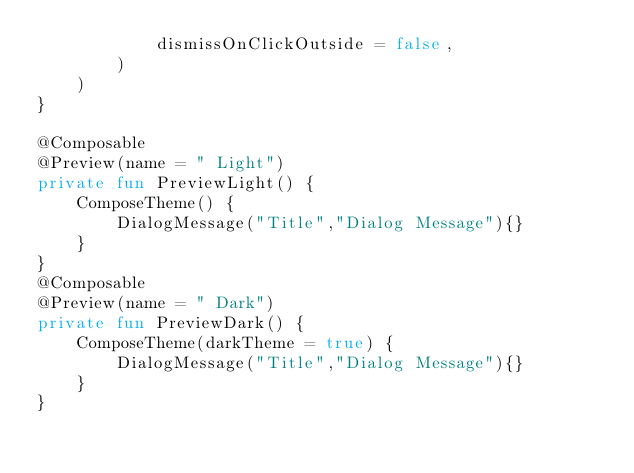Convert code to text. <code><loc_0><loc_0><loc_500><loc_500><_Kotlin_>            dismissOnClickOutside = false,
        )
    )
}

@Composable
@Preview(name = " Light")
private fun PreviewLight() {
    ComposeTheme() {
        DialogMessage("Title","Dialog Message"){}
    }
}
@Composable
@Preview(name = " Dark")
private fun PreviewDark() {
    ComposeTheme(darkTheme = true) {
        DialogMessage("Title","Dialog Message"){}
    }
}</code> 